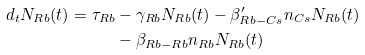<formula> <loc_0><loc_0><loc_500><loc_500>d _ { t } N _ { R b } ( t ) = \tau _ { R b } & - \gamma _ { R b } N _ { R b } ( t ) - \beta _ { R b - C s } ^ { \prime } n _ { C s } N _ { R b } ( t ) \\ & - \beta _ { R b - R b } n _ { R b } N _ { R b } ( t )</formula> 